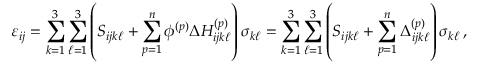Convert formula to latex. <formula><loc_0><loc_0><loc_500><loc_500>\varepsilon _ { i j } = \sum _ { k = 1 } ^ { 3 } \sum _ { \ell = 1 } ^ { 3 } \left ( S _ { i j k \ell } + \sum _ { p = 1 } ^ { n } \phi ^ { ( p ) } \Delta H _ { i j k \ell } ^ { ( p ) } \right ) \sigma _ { k \ell } = \sum _ { k = 1 } ^ { 3 } \sum _ { \ell = 1 } ^ { 3 } \left ( S _ { i j k \ell } + \sum _ { p = 1 } ^ { n } \Delta _ { i j k \ell } ^ { ( p ) } \right ) \sigma _ { k \ell } \, ,</formula> 